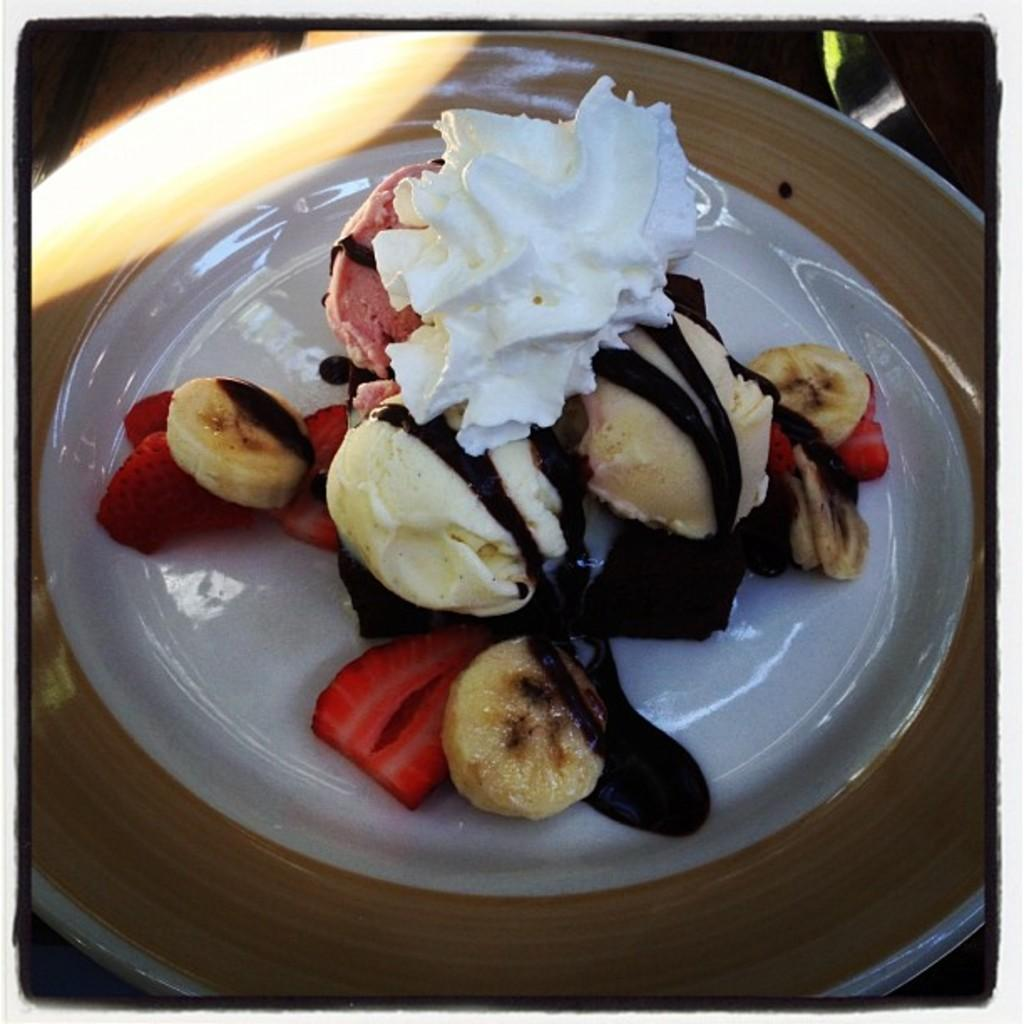What type of dessert is visible in the image? There is a piece of cake in the image. What other food items can be seen on the plate in the image? There are fruit pieces on the plate in the image. What type of berry is floating in the bubble in the image? There is no berry or bubble present in the image. 